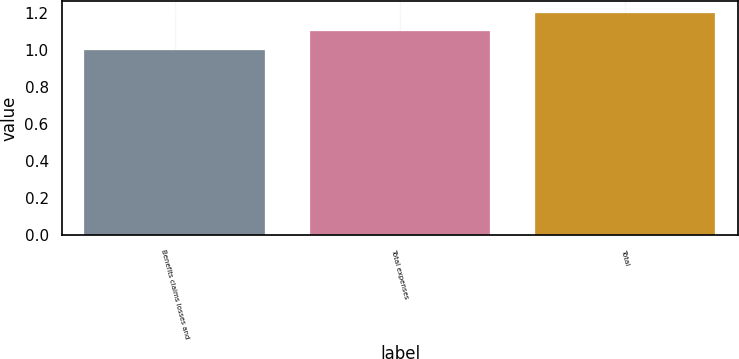Convert chart to OTSL. <chart><loc_0><loc_0><loc_500><loc_500><bar_chart><fcel>Benefits claims losses and<fcel>Total expenses<fcel>Total<nl><fcel>1<fcel>1.1<fcel>1.2<nl></chart> 